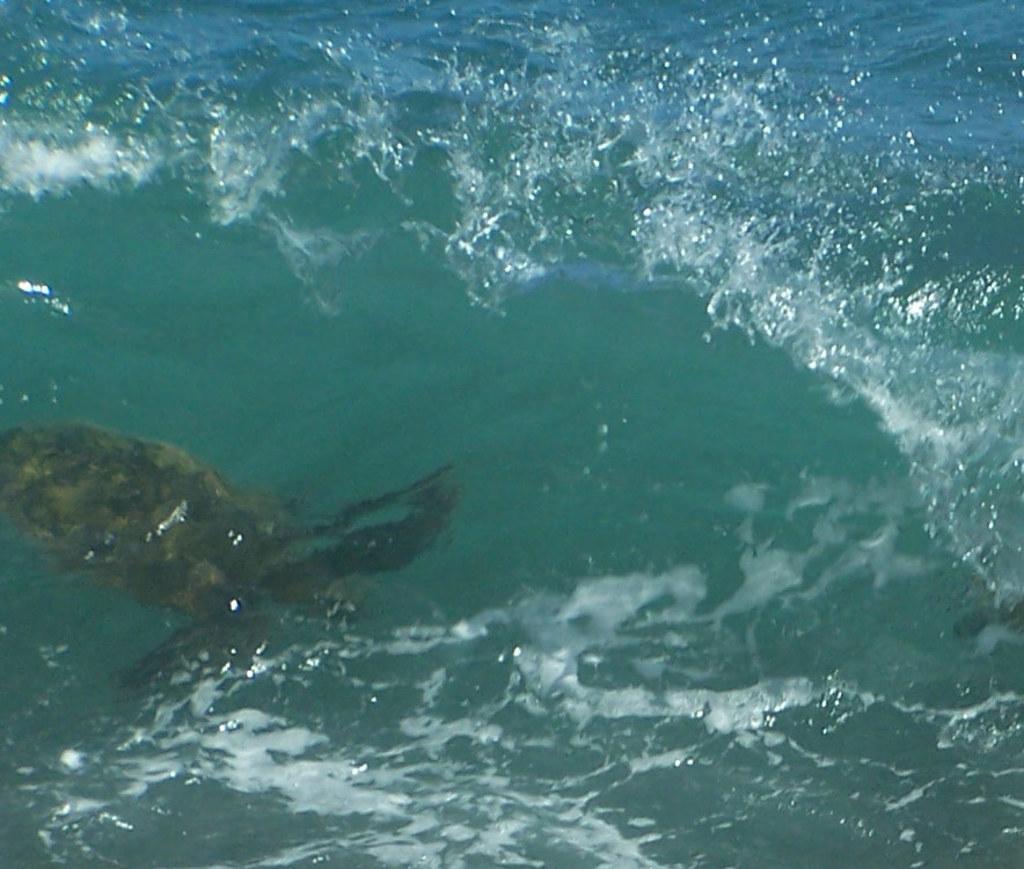How would you summarize this image in a sentence or two? In the image we can see water, in the water there is a water animal. 